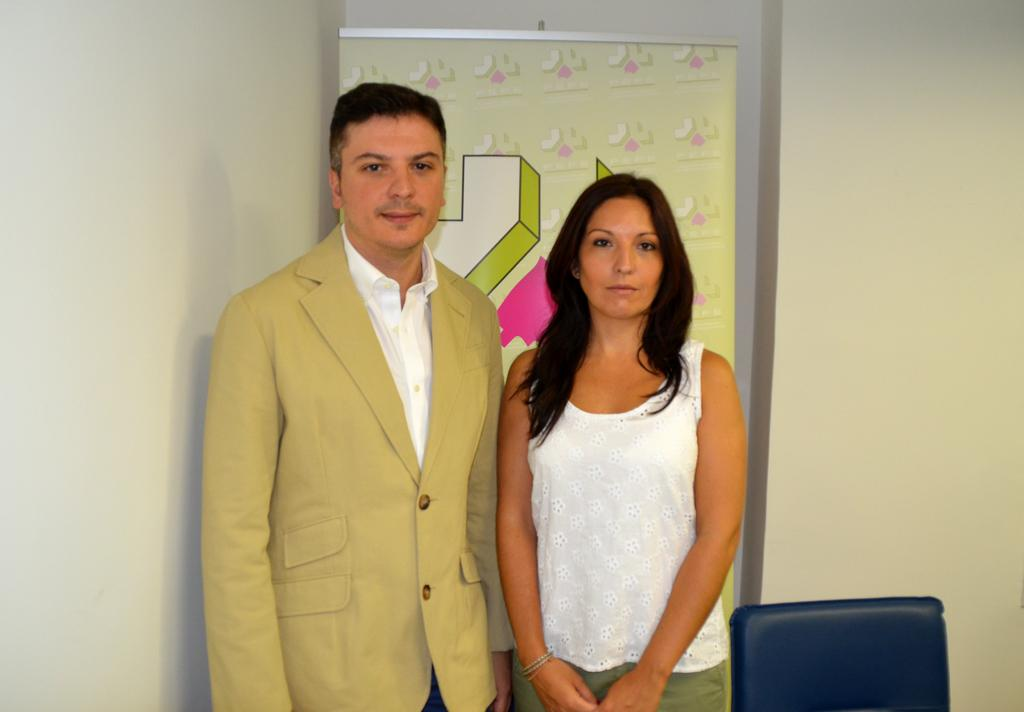What can be seen in the background of the image? There is a wall in the image. What is hanging on the wall? There is a banner in the image. What piece of furniture is present in the image? There is a chair in the image. How many people are in the image? There are two persons standing in the image. What is the woman wearing? The woman is wearing a white dress. What is the man wearing? The man is wearing a cream-colored jacket. What thought is the man having about the smell of the banner in the image? There is no indication of the man's thoughts or the smell of the banner in the image. 